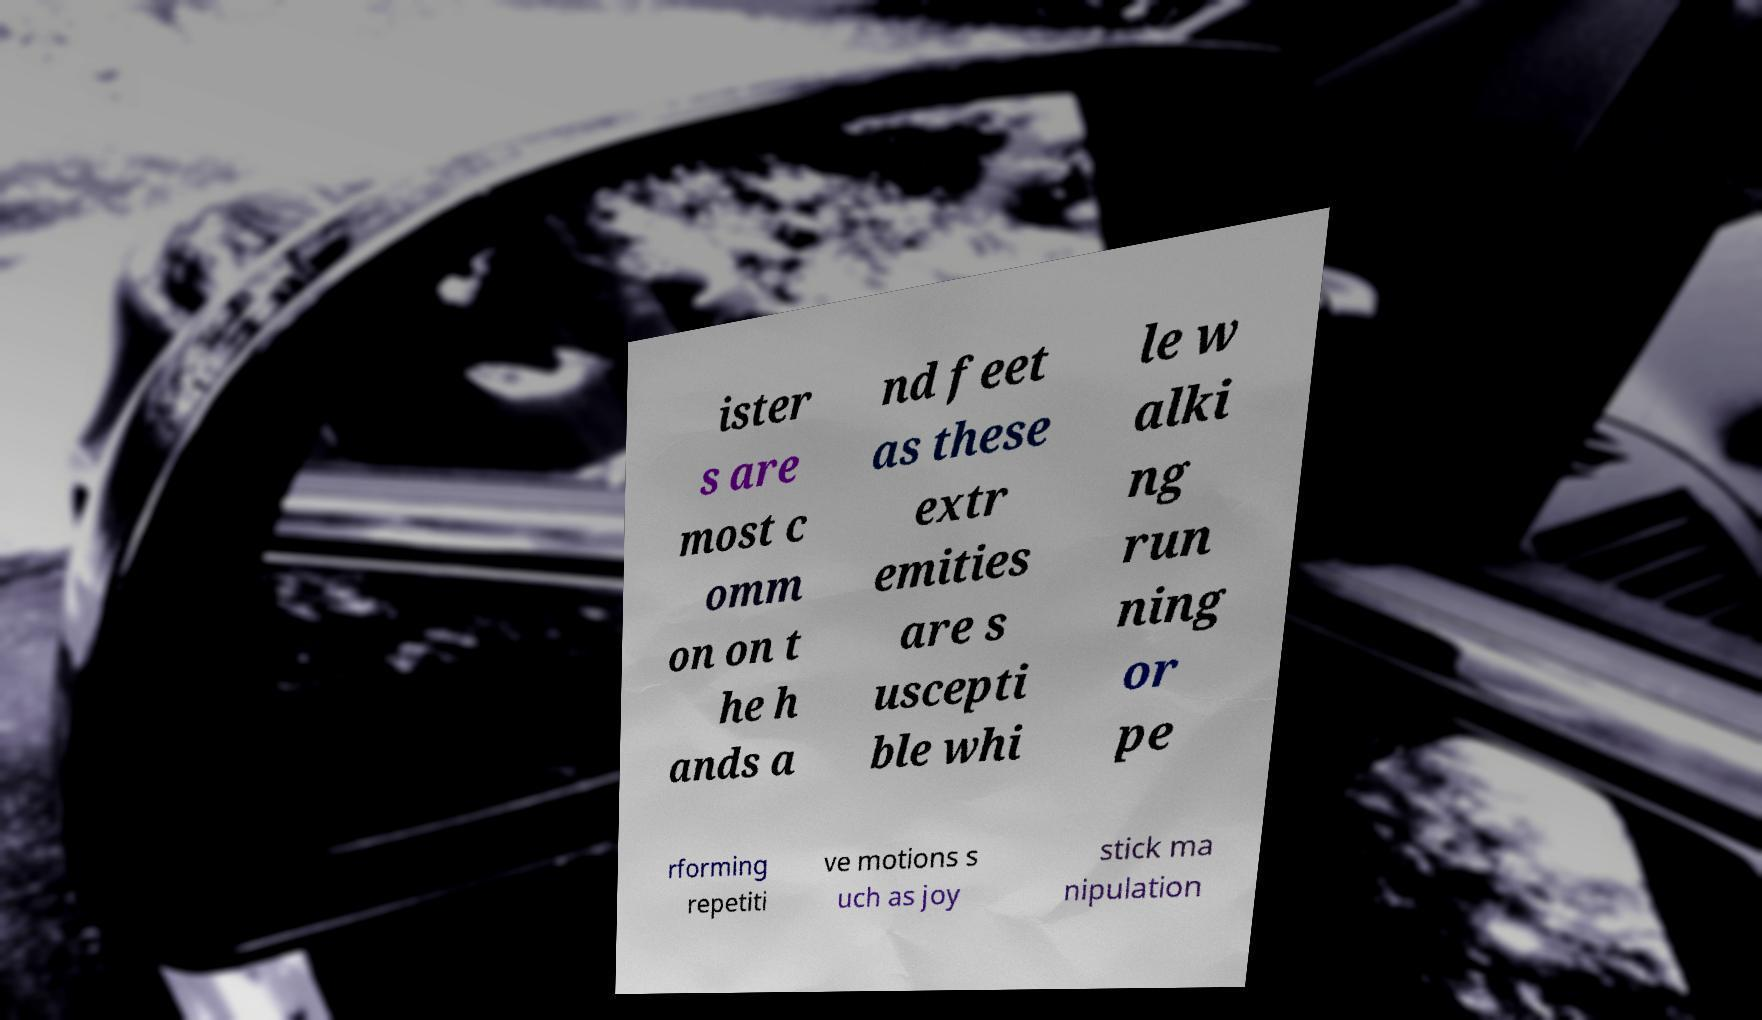What messages or text are displayed in this image? I need them in a readable, typed format. ister s are most c omm on on t he h ands a nd feet as these extr emities are s uscepti ble whi le w alki ng run ning or pe rforming repetiti ve motions s uch as joy stick ma nipulation 